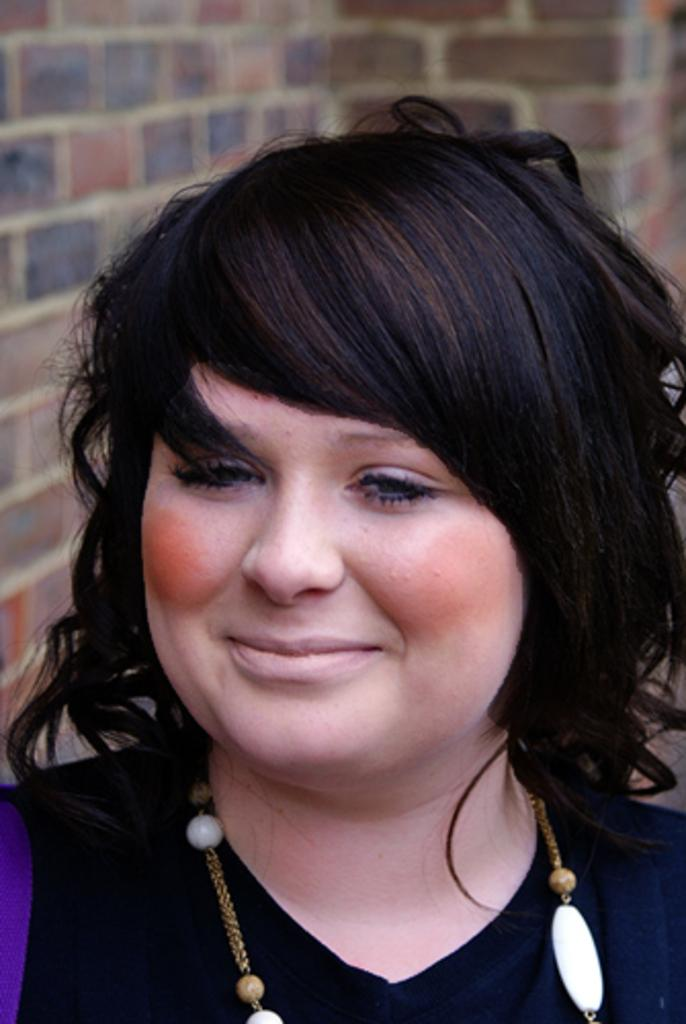Who is the main subject in the image? There is a woman in the image. What is the woman wearing in the image? The woman is wearing a chain in the image. How is the background of the woman depicted in the image? The background of the woman is blurred in the image. What type of hole can be seen in the woman's clothing in the image? There is no hole visible in the woman's clothing in the image. What type of burn can be seen on the woman's skin in the image? There is no burn visible on the woman's skin in the image. 